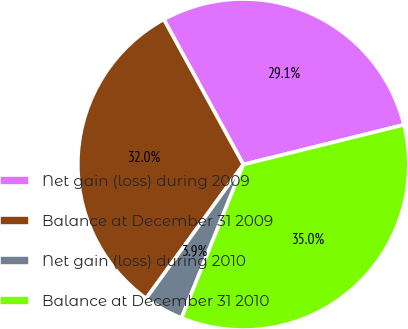Convert chart. <chart><loc_0><loc_0><loc_500><loc_500><pie_chart><fcel>Net gain (loss) during 2009<fcel>Balance at December 31 2009<fcel>Net gain (loss) during 2010<fcel>Balance at December 31 2010<nl><fcel>29.12%<fcel>32.03%<fcel>3.9%<fcel>34.95%<nl></chart> 